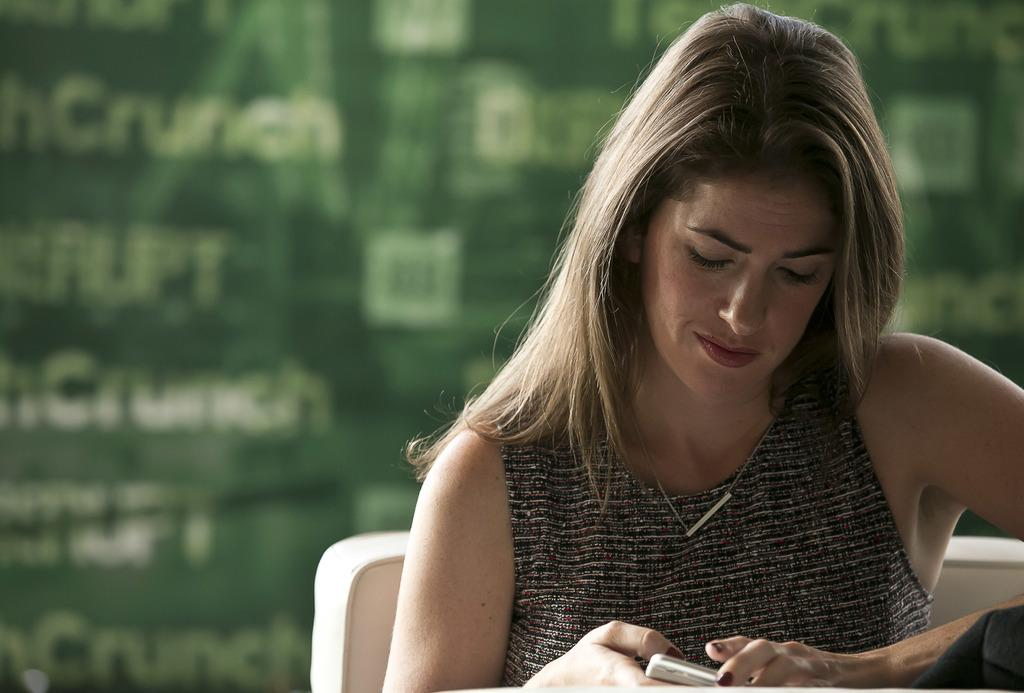Who is the main subject in the image? There is a woman in the image. Where is the woman located in the image? The woman is on the right side of the image. What is the woman wearing? The woman is wearing a T-shirt. Can you describe the color combination of the T-shirt? The T-shirt has a black and silver color combination. What is the woman holding in the image? The woman is holding a mobile. What is the woman doing in the image? The woman is sitting. How would you describe the background of the image? The background of the image is blurred. What type of snakes can be seen slithering in the background of the image? There are no snakes present in the image; the background is blurred. What town is visible in the background of the image? There is no town visible in the image; the background is blurred. 